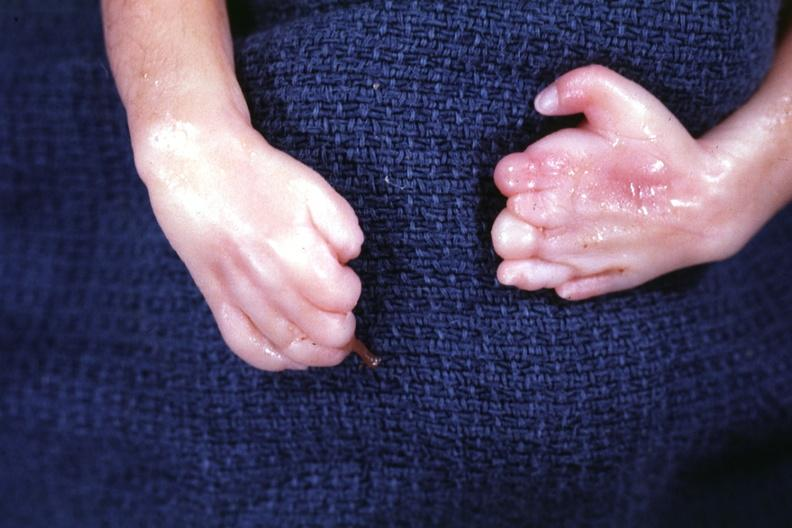what are present?
Answer the question using a single word or phrase. No 